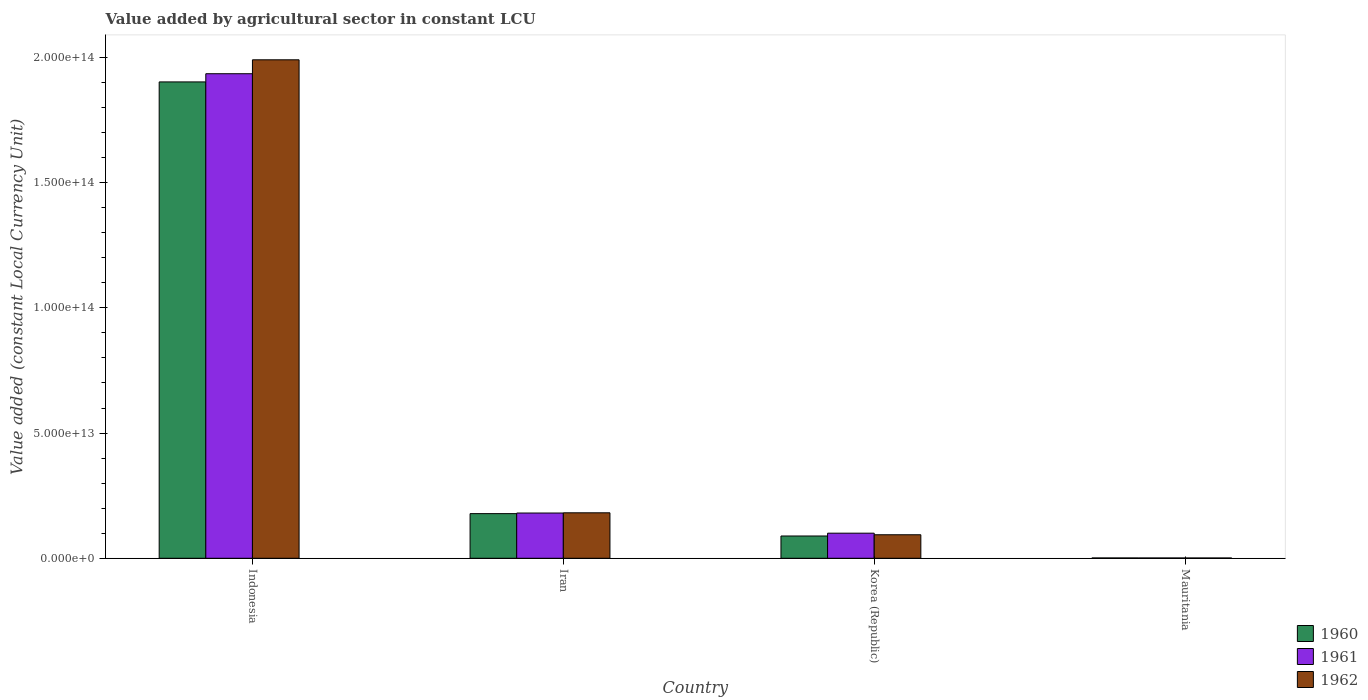How many different coloured bars are there?
Provide a succinct answer. 3. Are the number of bars per tick equal to the number of legend labels?
Your response must be concise. Yes. How many bars are there on the 1st tick from the left?
Offer a terse response. 3. How many bars are there on the 2nd tick from the right?
Give a very brief answer. 3. What is the label of the 2nd group of bars from the left?
Ensure brevity in your answer.  Iran. What is the value added by agricultural sector in 1960 in Iran?
Make the answer very short. 1.78e+13. Across all countries, what is the maximum value added by agricultural sector in 1960?
Your answer should be very brief. 1.90e+14. Across all countries, what is the minimum value added by agricultural sector in 1960?
Provide a short and direct response. 1.27e+11. In which country was the value added by agricultural sector in 1962 minimum?
Offer a very short reply. Mauritania. What is the total value added by agricultural sector in 1962 in the graph?
Give a very brief answer. 2.27e+14. What is the difference between the value added by agricultural sector in 1962 in Indonesia and that in Iran?
Provide a succinct answer. 1.81e+14. What is the difference between the value added by agricultural sector in 1961 in Indonesia and the value added by agricultural sector in 1962 in Iran?
Offer a very short reply. 1.75e+14. What is the average value added by agricultural sector in 1961 per country?
Ensure brevity in your answer.  5.54e+13. What is the difference between the value added by agricultural sector of/in 1960 and value added by agricultural sector of/in 1961 in Korea (Republic)?
Offer a very short reply. -1.12e+12. In how many countries, is the value added by agricultural sector in 1962 greater than 70000000000000 LCU?
Offer a terse response. 1. What is the ratio of the value added by agricultural sector in 1962 in Korea (Republic) to that in Mauritania?
Make the answer very short. 78.51. Is the value added by agricultural sector in 1960 in Iran less than that in Mauritania?
Offer a very short reply. No. Is the difference between the value added by agricultural sector in 1960 in Iran and Korea (Republic) greater than the difference between the value added by agricultural sector in 1961 in Iran and Korea (Republic)?
Your answer should be compact. Yes. What is the difference between the highest and the second highest value added by agricultural sector in 1962?
Offer a very short reply. -8.77e+12. What is the difference between the highest and the lowest value added by agricultural sector in 1960?
Your response must be concise. 1.90e+14. In how many countries, is the value added by agricultural sector in 1961 greater than the average value added by agricultural sector in 1961 taken over all countries?
Give a very brief answer. 1. Is the sum of the value added by agricultural sector in 1960 in Korea (Republic) and Mauritania greater than the maximum value added by agricultural sector in 1961 across all countries?
Offer a terse response. No. Is it the case that in every country, the sum of the value added by agricultural sector in 1961 and value added by agricultural sector in 1960 is greater than the value added by agricultural sector in 1962?
Keep it short and to the point. Yes. How many bars are there?
Your answer should be very brief. 12. What is the difference between two consecutive major ticks on the Y-axis?
Provide a short and direct response. 5.00e+13. Are the values on the major ticks of Y-axis written in scientific E-notation?
Give a very brief answer. Yes. How are the legend labels stacked?
Ensure brevity in your answer.  Vertical. What is the title of the graph?
Provide a succinct answer. Value added by agricultural sector in constant LCU. What is the label or title of the Y-axis?
Ensure brevity in your answer.  Value added (constant Local Currency Unit). What is the Value added (constant Local Currency Unit) of 1960 in Indonesia?
Offer a terse response. 1.90e+14. What is the Value added (constant Local Currency Unit) in 1961 in Indonesia?
Give a very brief answer. 1.94e+14. What is the Value added (constant Local Currency Unit) in 1962 in Indonesia?
Your answer should be compact. 1.99e+14. What is the Value added (constant Local Currency Unit) of 1960 in Iran?
Provide a succinct answer. 1.78e+13. What is the Value added (constant Local Currency Unit) of 1961 in Iran?
Provide a short and direct response. 1.81e+13. What is the Value added (constant Local Currency Unit) of 1962 in Iran?
Offer a terse response. 1.82e+13. What is the Value added (constant Local Currency Unit) of 1960 in Korea (Republic)?
Ensure brevity in your answer.  8.90e+12. What is the Value added (constant Local Currency Unit) in 1961 in Korea (Republic)?
Your answer should be compact. 1.00e+13. What is the Value added (constant Local Currency Unit) of 1962 in Korea (Republic)?
Offer a terse response. 9.39e+12. What is the Value added (constant Local Currency Unit) of 1960 in Mauritania?
Your response must be concise. 1.27e+11. What is the Value added (constant Local Currency Unit) in 1961 in Mauritania?
Provide a succinct answer. 1.23e+11. What is the Value added (constant Local Currency Unit) in 1962 in Mauritania?
Ensure brevity in your answer.  1.20e+11. Across all countries, what is the maximum Value added (constant Local Currency Unit) of 1960?
Provide a short and direct response. 1.90e+14. Across all countries, what is the maximum Value added (constant Local Currency Unit) in 1961?
Your answer should be compact. 1.94e+14. Across all countries, what is the maximum Value added (constant Local Currency Unit) of 1962?
Offer a very short reply. 1.99e+14. Across all countries, what is the minimum Value added (constant Local Currency Unit) in 1960?
Your answer should be very brief. 1.27e+11. Across all countries, what is the minimum Value added (constant Local Currency Unit) of 1961?
Your answer should be very brief. 1.23e+11. Across all countries, what is the minimum Value added (constant Local Currency Unit) in 1962?
Provide a succinct answer. 1.20e+11. What is the total Value added (constant Local Currency Unit) in 1960 in the graph?
Ensure brevity in your answer.  2.17e+14. What is the total Value added (constant Local Currency Unit) in 1961 in the graph?
Offer a very short reply. 2.22e+14. What is the total Value added (constant Local Currency Unit) of 1962 in the graph?
Offer a very short reply. 2.27e+14. What is the difference between the Value added (constant Local Currency Unit) in 1960 in Indonesia and that in Iran?
Provide a short and direct response. 1.72e+14. What is the difference between the Value added (constant Local Currency Unit) of 1961 in Indonesia and that in Iran?
Keep it short and to the point. 1.75e+14. What is the difference between the Value added (constant Local Currency Unit) of 1962 in Indonesia and that in Iran?
Your answer should be compact. 1.81e+14. What is the difference between the Value added (constant Local Currency Unit) in 1960 in Indonesia and that in Korea (Republic)?
Provide a short and direct response. 1.81e+14. What is the difference between the Value added (constant Local Currency Unit) of 1961 in Indonesia and that in Korea (Republic)?
Give a very brief answer. 1.83e+14. What is the difference between the Value added (constant Local Currency Unit) in 1962 in Indonesia and that in Korea (Republic)?
Give a very brief answer. 1.90e+14. What is the difference between the Value added (constant Local Currency Unit) in 1960 in Indonesia and that in Mauritania?
Offer a terse response. 1.90e+14. What is the difference between the Value added (constant Local Currency Unit) of 1961 in Indonesia and that in Mauritania?
Keep it short and to the point. 1.93e+14. What is the difference between the Value added (constant Local Currency Unit) in 1962 in Indonesia and that in Mauritania?
Make the answer very short. 1.99e+14. What is the difference between the Value added (constant Local Currency Unit) in 1960 in Iran and that in Korea (Republic)?
Provide a succinct answer. 8.93e+12. What is the difference between the Value added (constant Local Currency Unit) of 1961 in Iran and that in Korea (Republic)?
Ensure brevity in your answer.  8.05e+12. What is the difference between the Value added (constant Local Currency Unit) in 1962 in Iran and that in Korea (Republic)?
Offer a terse response. 8.77e+12. What is the difference between the Value added (constant Local Currency Unit) of 1960 in Iran and that in Mauritania?
Your answer should be very brief. 1.77e+13. What is the difference between the Value added (constant Local Currency Unit) in 1961 in Iran and that in Mauritania?
Offer a very short reply. 1.79e+13. What is the difference between the Value added (constant Local Currency Unit) of 1962 in Iran and that in Mauritania?
Provide a succinct answer. 1.80e+13. What is the difference between the Value added (constant Local Currency Unit) of 1960 in Korea (Republic) and that in Mauritania?
Offer a terse response. 8.77e+12. What is the difference between the Value added (constant Local Currency Unit) in 1961 in Korea (Republic) and that in Mauritania?
Your answer should be very brief. 9.90e+12. What is the difference between the Value added (constant Local Currency Unit) of 1962 in Korea (Republic) and that in Mauritania?
Your answer should be very brief. 9.27e+12. What is the difference between the Value added (constant Local Currency Unit) in 1960 in Indonesia and the Value added (constant Local Currency Unit) in 1961 in Iran?
Provide a short and direct response. 1.72e+14. What is the difference between the Value added (constant Local Currency Unit) in 1960 in Indonesia and the Value added (constant Local Currency Unit) in 1962 in Iran?
Offer a very short reply. 1.72e+14. What is the difference between the Value added (constant Local Currency Unit) in 1961 in Indonesia and the Value added (constant Local Currency Unit) in 1962 in Iran?
Your answer should be compact. 1.75e+14. What is the difference between the Value added (constant Local Currency Unit) in 1960 in Indonesia and the Value added (constant Local Currency Unit) in 1961 in Korea (Republic)?
Ensure brevity in your answer.  1.80e+14. What is the difference between the Value added (constant Local Currency Unit) of 1960 in Indonesia and the Value added (constant Local Currency Unit) of 1962 in Korea (Republic)?
Provide a succinct answer. 1.81e+14. What is the difference between the Value added (constant Local Currency Unit) of 1961 in Indonesia and the Value added (constant Local Currency Unit) of 1962 in Korea (Republic)?
Your response must be concise. 1.84e+14. What is the difference between the Value added (constant Local Currency Unit) in 1960 in Indonesia and the Value added (constant Local Currency Unit) in 1961 in Mauritania?
Ensure brevity in your answer.  1.90e+14. What is the difference between the Value added (constant Local Currency Unit) of 1960 in Indonesia and the Value added (constant Local Currency Unit) of 1962 in Mauritania?
Your response must be concise. 1.90e+14. What is the difference between the Value added (constant Local Currency Unit) of 1961 in Indonesia and the Value added (constant Local Currency Unit) of 1962 in Mauritania?
Offer a terse response. 1.93e+14. What is the difference between the Value added (constant Local Currency Unit) in 1960 in Iran and the Value added (constant Local Currency Unit) in 1961 in Korea (Republic)?
Provide a succinct answer. 7.81e+12. What is the difference between the Value added (constant Local Currency Unit) of 1960 in Iran and the Value added (constant Local Currency Unit) of 1962 in Korea (Republic)?
Offer a terse response. 8.44e+12. What is the difference between the Value added (constant Local Currency Unit) in 1961 in Iran and the Value added (constant Local Currency Unit) in 1962 in Korea (Republic)?
Provide a short and direct response. 8.68e+12. What is the difference between the Value added (constant Local Currency Unit) of 1960 in Iran and the Value added (constant Local Currency Unit) of 1961 in Mauritania?
Give a very brief answer. 1.77e+13. What is the difference between the Value added (constant Local Currency Unit) in 1960 in Iran and the Value added (constant Local Currency Unit) in 1962 in Mauritania?
Ensure brevity in your answer.  1.77e+13. What is the difference between the Value added (constant Local Currency Unit) in 1961 in Iran and the Value added (constant Local Currency Unit) in 1962 in Mauritania?
Provide a short and direct response. 1.80e+13. What is the difference between the Value added (constant Local Currency Unit) of 1960 in Korea (Republic) and the Value added (constant Local Currency Unit) of 1961 in Mauritania?
Your answer should be very brief. 8.77e+12. What is the difference between the Value added (constant Local Currency Unit) of 1960 in Korea (Republic) and the Value added (constant Local Currency Unit) of 1962 in Mauritania?
Offer a terse response. 8.78e+12. What is the difference between the Value added (constant Local Currency Unit) of 1961 in Korea (Republic) and the Value added (constant Local Currency Unit) of 1962 in Mauritania?
Give a very brief answer. 9.90e+12. What is the average Value added (constant Local Currency Unit) of 1960 per country?
Offer a very short reply. 5.43e+13. What is the average Value added (constant Local Currency Unit) of 1961 per country?
Your answer should be very brief. 5.54e+13. What is the average Value added (constant Local Currency Unit) in 1962 per country?
Offer a very short reply. 5.67e+13. What is the difference between the Value added (constant Local Currency Unit) in 1960 and Value added (constant Local Currency Unit) in 1961 in Indonesia?
Offer a terse response. -3.27e+12. What is the difference between the Value added (constant Local Currency Unit) of 1960 and Value added (constant Local Currency Unit) of 1962 in Indonesia?
Your response must be concise. -8.83e+12. What is the difference between the Value added (constant Local Currency Unit) in 1961 and Value added (constant Local Currency Unit) in 1962 in Indonesia?
Give a very brief answer. -5.56e+12. What is the difference between the Value added (constant Local Currency Unit) of 1960 and Value added (constant Local Currency Unit) of 1961 in Iran?
Your answer should be compact. -2.42e+11. What is the difference between the Value added (constant Local Currency Unit) of 1960 and Value added (constant Local Currency Unit) of 1962 in Iran?
Make the answer very short. -3.32e+11. What is the difference between the Value added (constant Local Currency Unit) of 1961 and Value added (constant Local Currency Unit) of 1962 in Iran?
Ensure brevity in your answer.  -8.95e+1. What is the difference between the Value added (constant Local Currency Unit) in 1960 and Value added (constant Local Currency Unit) in 1961 in Korea (Republic)?
Offer a terse response. -1.12e+12. What is the difference between the Value added (constant Local Currency Unit) in 1960 and Value added (constant Local Currency Unit) in 1962 in Korea (Republic)?
Ensure brevity in your answer.  -4.93e+11. What is the difference between the Value added (constant Local Currency Unit) in 1961 and Value added (constant Local Currency Unit) in 1962 in Korea (Republic)?
Make the answer very short. 6.31e+11. What is the difference between the Value added (constant Local Currency Unit) of 1960 and Value added (constant Local Currency Unit) of 1961 in Mauritania?
Your response must be concise. 4.01e+09. What is the difference between the Value added (constant Local Currency Unit) in 1960 and Value added (constant Local Currency Unit) in 1962 in Mauritania?
Give a very brief answer. 7.67e+09. What is the difference between the Value added (constant Local Currency Unit) in 1961 and Value added (constant Local Currency Unit) in 1962 in Mauritania?
Ensure brevity in your answer.  3.65e+09. What is the ratio of the Value added (constant Local Currency Unit) of 1960 in Indonesia to that in Iran?
Ensure brevity in your answer.  10.67. What is the ratio of the Value added (constant Local Currency Unit) of 1961 in Indonesia to that in Iran?
Provide a succinct answer. 10.71. What is the ratio of the Value added (constant Local Currency Unit) of 1962 in Indonesia to that in Iran?
Offer a very short reply. 10.96. What is the ratio of the Value added (constant Local Currency Unit) of 1960 in Indonesia to that in Korea (Republic)?
Make the answer very short. 21.38. What is the ratio of the Value added (constant Local Currency Unit) in 1961 in Indonesia to that in Korea (Republic)?
Offer a very short reply. 19.31. What is the ratio of the Value added (constant Local Currency Unit) of 1962 in Indonesia to that in Korea (Republic)?
Ensure brevity in your answer.  21.2. What is the ratio of the Value added (constant Local Currency Unit) of 1960 in Indonesia to that in Mauritania?
Keep it short and to the point. 1494.5. What is the ratio of the Value added (constant Local Currency Unit) in 1961 in Indonesia to that in Mauritania?
Offer a terse response. 1569.7. What is the ratio of the Value added (constant Local Currency Unit) in 1962 in Indonesia to that in Mauritania?
Provide a succinct answer. 1664.14. What is the ratio of the Value added (constant Local Currency Unit) in 1960 in Iran to that in Korea (Republic)?
Offer a terse response. 2. What is the ratio of the Value added (constant Local Currency Unit) in 1961 in Iran to that in Korea (Republic)?
Offer a very short reply. 1.8. What is the ratio of the Value added (constant Local Currency Unit) of 1962 in Iran to that in Korea (Republic)?
Keep it short and to the point. 1.93. What is the ratio of the Value added (constant Local Currency Unit) of 1960 in Iran to that in Mauritania?
Provide a succinct answer. 140.05. What is the ratio of the Value added (constant Local Currency Unit) of 1961 in Iran to that in Mauritania?
Keep it short and to the point. 146.57. What is the ratio of the Value added (constant Local Currency Unit) of 1962 in Iran to that in Mauritania?
Provide a succinct answer. 151.8. What is the ratio of the Value added (constant Local Currency Unit) in 1960 in Korea (Republic) to that in Mauritania?
Your response must be concise. 69.9. What is the ratio of the Value added (constant Local Currency Unit) of 1961 in Korea (Republic) to that in Mauritania?
Give a very brief answer. 81.29. What is the ratio of the Value added (constant Local Currency Unit) of 1962 in Korea (Republic) to that in Mauritania?
Provide a succinct answer. 78.51. What is the difference between the highest and the second highest Value added (constant Local Currency Unit) of 1960?
Ensure brevity in your answer.  1.72e+14. What is the difference between the highest and the second highest Value added (constant Local Currency Unit) of 1961?
Ensure brevity in your answer.  1.75e+14. What is the difference between the highest and the second highest Value added (constant Local Currency Unit) of 1962?
Your answer should be compact. 1.81e+14. What is the difference between the highest and the lowest Value added (constant Local Currency Unit) in 1960?
Your answer should be compact. 1.90e+14. What is the difference between the highest and the lowest Value added (constant Local Currency Unit) of 1961?
Offer a very short reply. 1.93e+14. What is the difference between the highest and the lowest Value added (constant Local Currency Unit) in 1962?
Provide a succinct answer. 1.99e+14. 